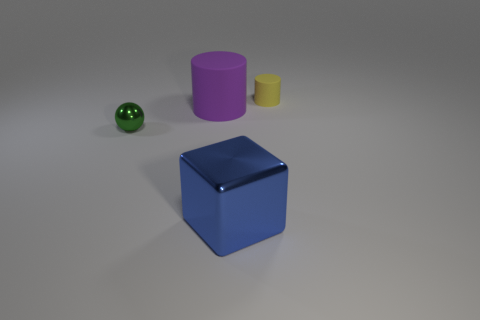What is the color of the thing that is to the right of the large purple cylinder and behind the tiny metal ball? The object positioned to the right of the large purple cylinder and behind the tiny metal ball appears to be a small yellow cylinder. Its muted yellow color contrasts subtly with the surrounding objects. 